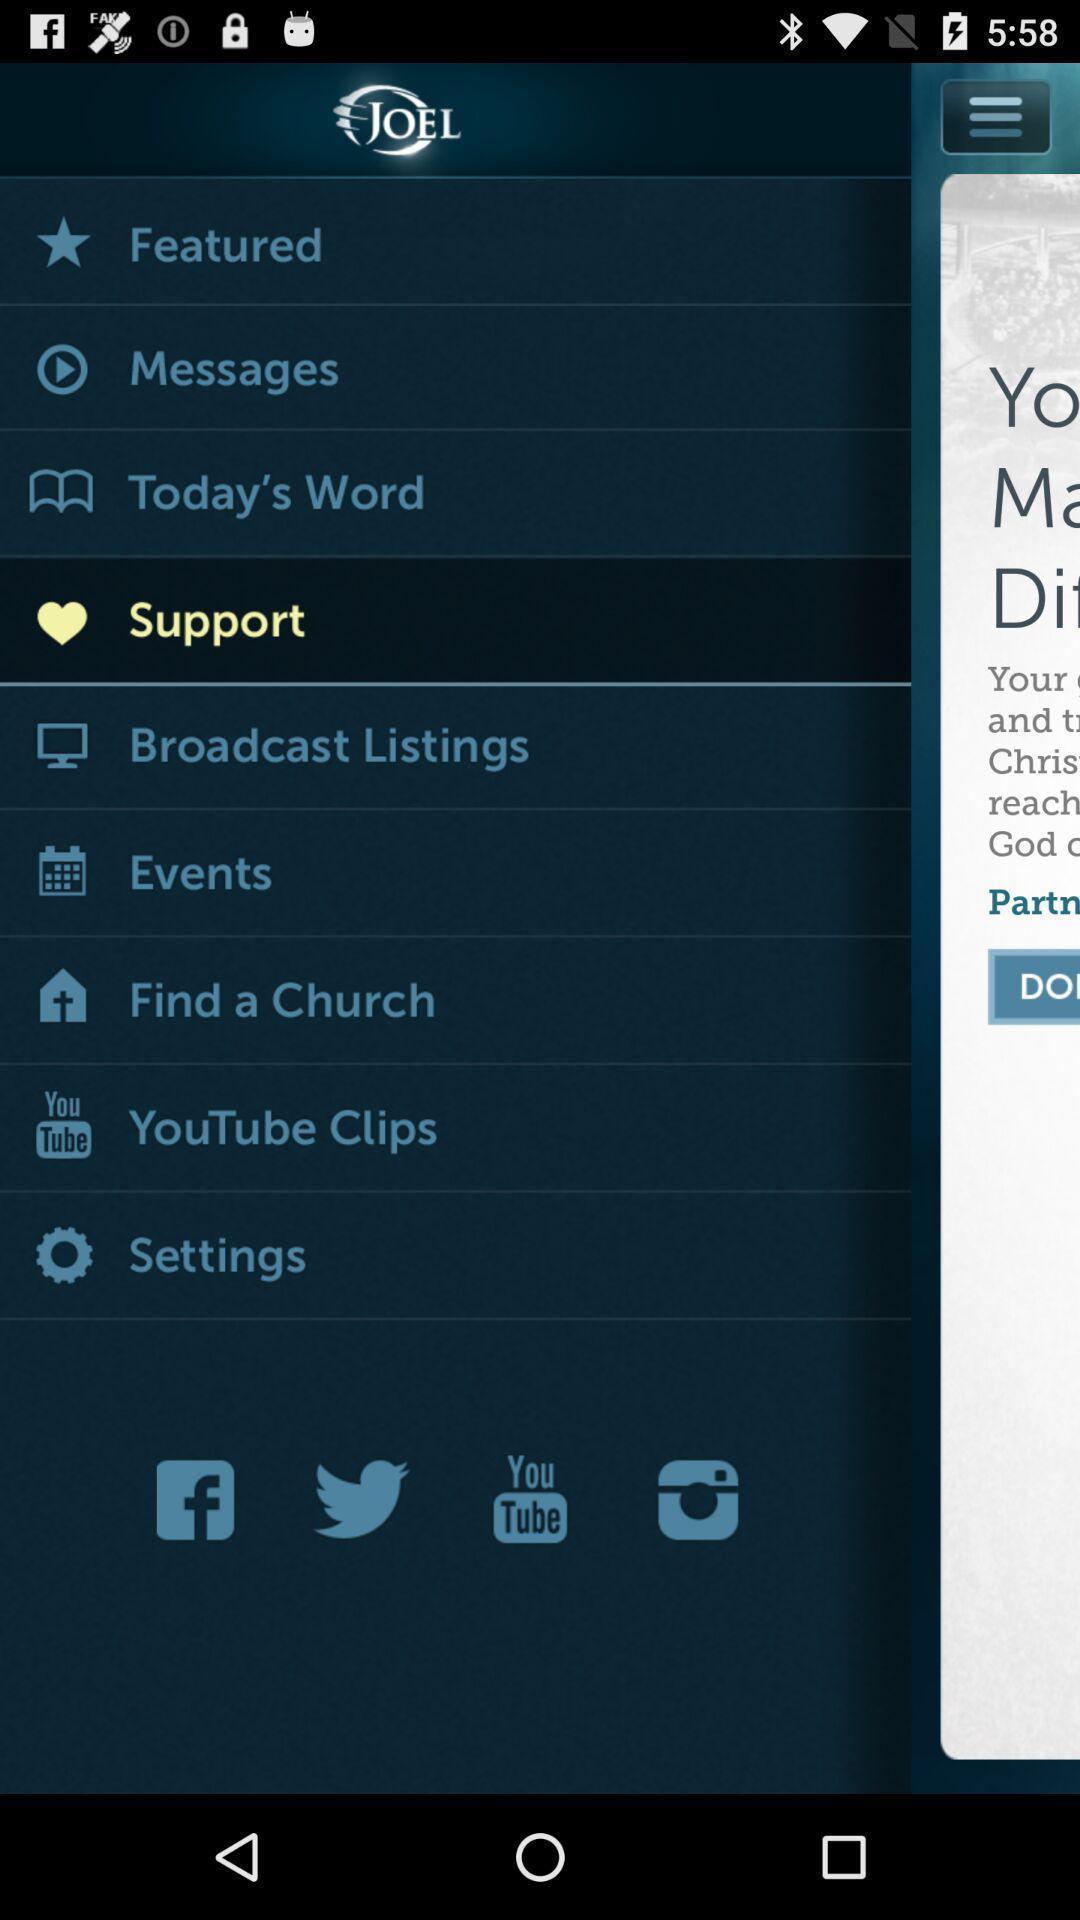Provide a description of this screenshot. Page showing options. 